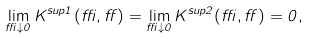<formula> <loc_0><loc_0><loc_500><loc_500>\lim _ { \delta \downarrow 0 } K ^ { s u p { 1 } } ( \delta , \alpha ) = \lim _ { \delta \downarrow 0 } K ^ { s u p { 2 } } ( \delta , \alpha ) = 0 ,</formula> 